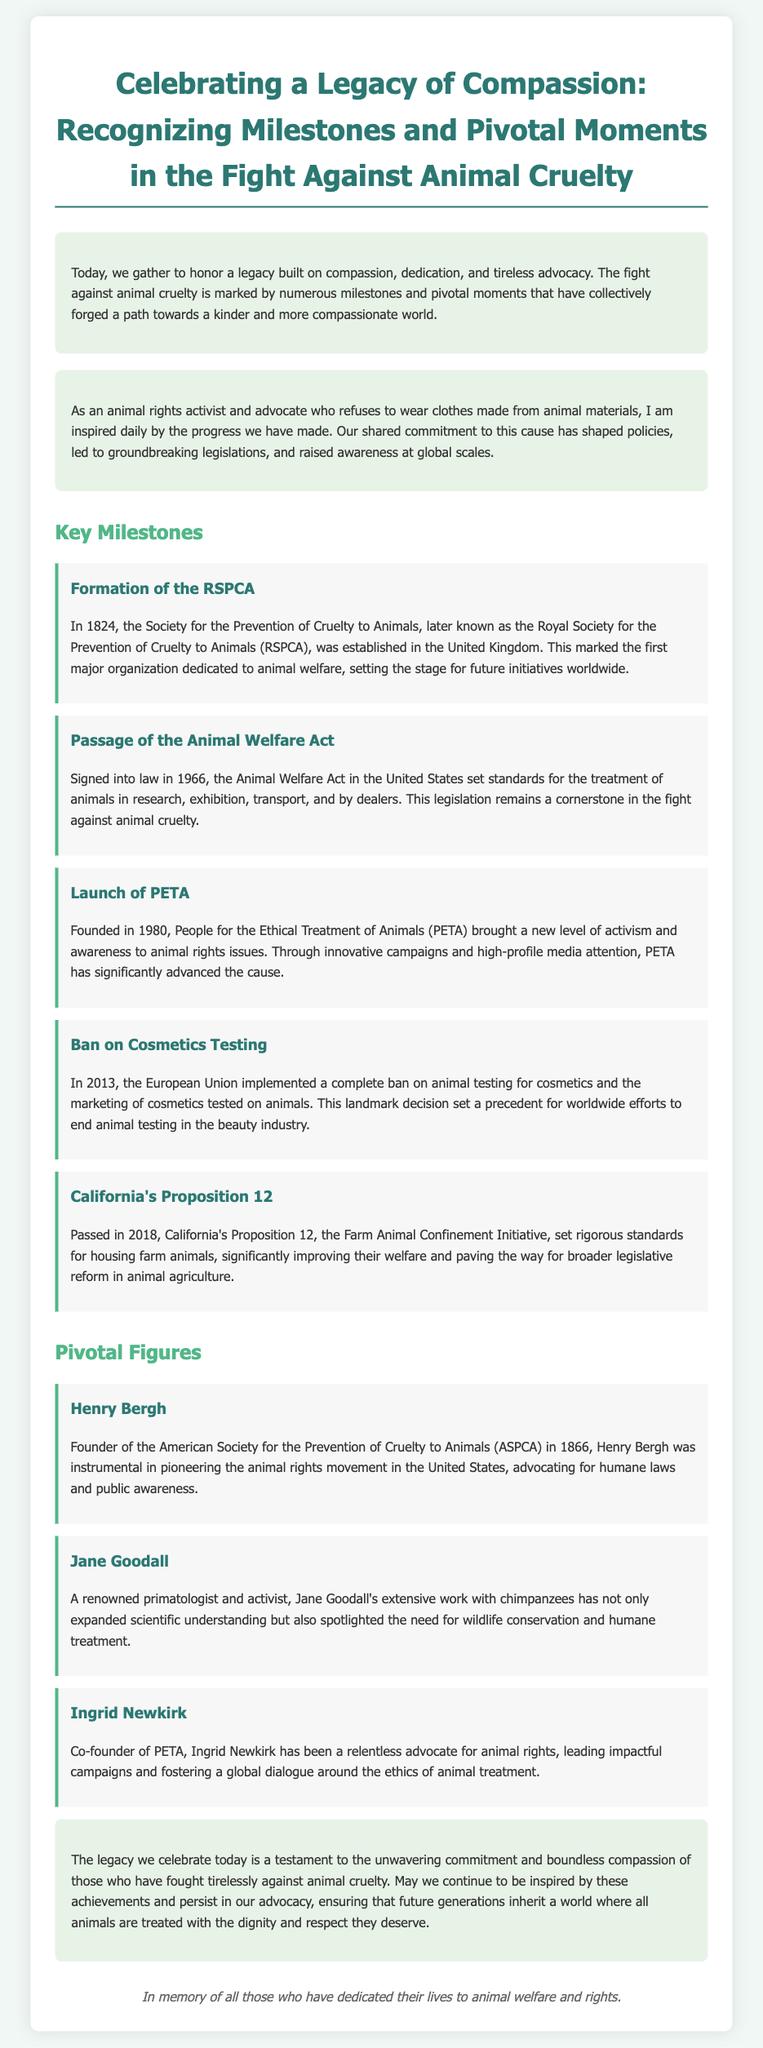What year was the RSPCA established? The establishment year of the RSPCA is mentioned in the document.
Answer: 1824 What does PETA stand for? The document provides the full form of the acronym PETA.
Answer: People for the Ethical Treatment of Animals What significant legislation was passed in 1966? The document specifies a major law that was signed in 1966 related to animal welfare.
Answer: Animal Welfare Act Which landmark decision was made in 2013? The document details a significant action taken by the European Union in 2013 concerning animal testing.
Answer: Complete ban on animal testing for cosmetics Who founded the ASPCA? The founder of the ASPCA is identified in the document.
Answer: Henry Bergh What major initiative in California was passed in 2018? The document refers to a specific initiative focused on animal confinement that was passed in California in 2018.
Answer: Proposition 12 What is highlighted in the conclusion of the eulogy? The conclusion summarizes the main theme or message conveyed about animal welfare.
Answer: Commitment and compassion Who is recognized for pioneering the animal rights movement in the US? The document mentions a key figure known for developing the animal rights movement in the United States.
Answer: Henry Bergh What does the eulogy aim to inspire in future generations? The eulogy discusses a particular sentiment or action that should be carried forward for animal advocacy.
Answer: Advocacy for animals 